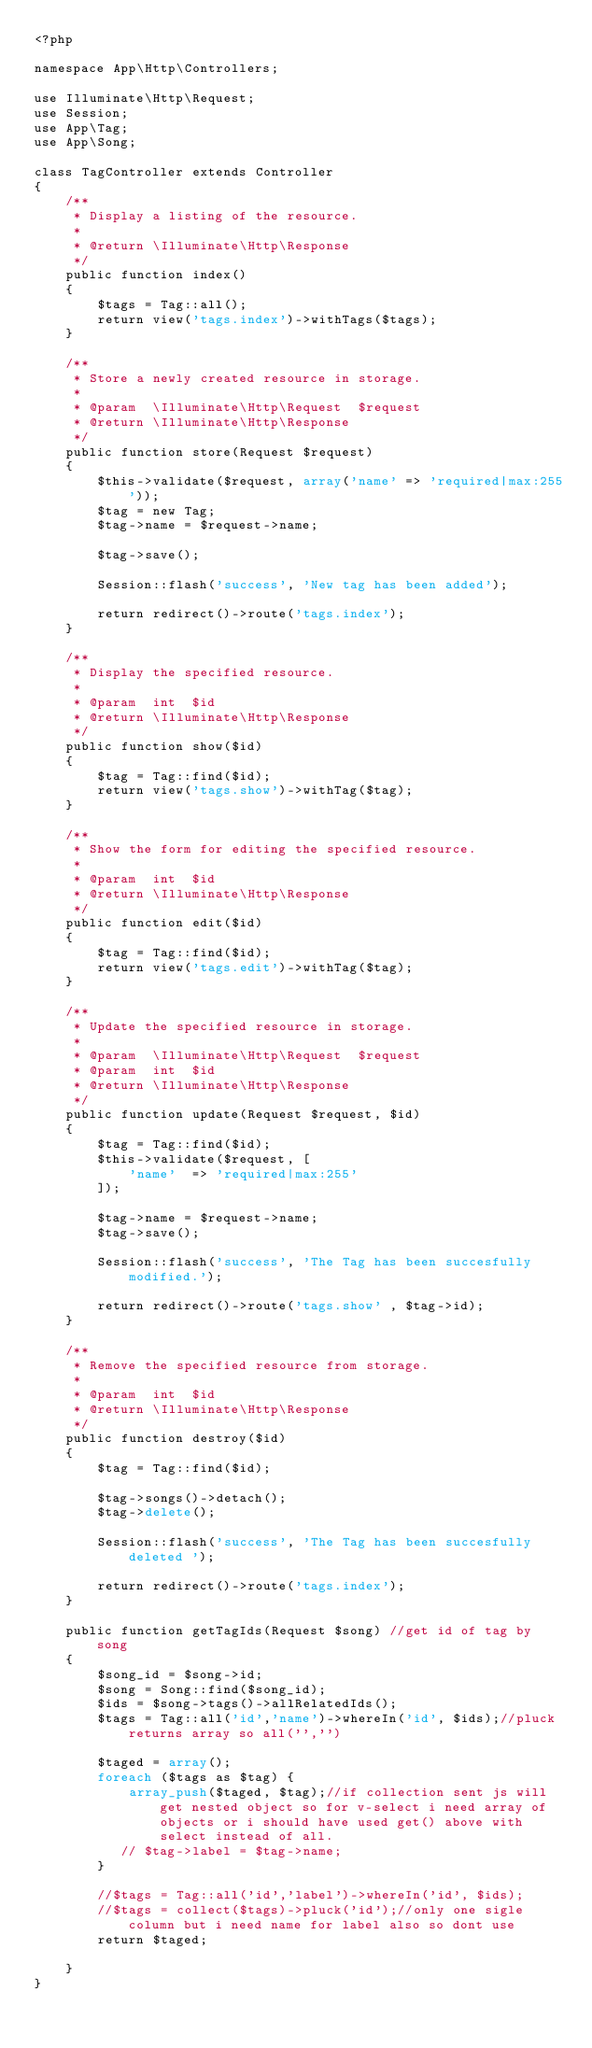Convert code to text. <code><loc_0><loc_0><loc_500><loc_500><_PHP_><?php

namespace App\Http\Controllers;

use Illuminate\Http\Request;
use Session;
use App\Tag;
use App\Song;

class TagController extends Controller
{
    /**
     * Display a listing of the resource.
     *
     * @return \Illuminate\Http\Response
     */
    public function index()
    {
        $tags = Tag::all();
        return view('tags.index')->withTags($tags);
    }

    /**
     * Store a newly created resource in storage.
     *
     * @param  \Illuminate\Http\Request  $request
     * @return \Illuminate\Http\Response
     */
    public function store(Request $request)
    {
        $this->validate($request, array('name' => 'required|max:255'));
        $tag = new Tag;
        $tag->name = $request->name;

        $tag->save();

        Session::flash('success', 'New tag has been added');

        return redirect()->route('tags.index');
    }

    /**
     * Display the specified resource.
     *
     * @param  int  $id
     * @return \Illuminate\Http\Response
     */
    public function show($id)
    {
        $tag = Tag::find($id);
        return view('tags.show')->withTag($tag);
    }

    /**
     * Show the form for editing the specified resource.
     *
     * @param  int  $id
     * @return \Illuminate\Http\Response
     */
    public function edit($id)
    {
        $tag = Tag::find($id);
        return view('tags.edit')->withTag($tag);
    }

    /**
     * Update the specified resource in storage.
     *
     * @param  \Illuminate\Http\Request  $request
     * @param  int  $id
     * @return \Illuminate\Http\Response
     */
    public function update(Request $request, $id)
    {   
        $tag = Tag::find($id);
        $this->validate($request, [
            'name'  => 'required|max:255'
        ]);

        $tag->name = $request->name;
        $tag->save(); 

        Session::flash('success', 'The Tag has been succesfully modified.');

        return redirect()->route('tags.show' , $tag->id);
    }

    /**
     * Remove the specified resource from storage.
     *
     * @param  int  $id
     * @return \Illuminate\Http\Response
     */
    public function destroy($id)
    {
        $tag = Tag::find($id);

        $tag->songs()->detach();
        $tag->delete();

        Session::flash('success', 'The Tag has been succesfully deleted ');

        return redirect()->route('tags.index');
    }

    public function getTagIds(Request $song) //get id of tag by song 
    { 
        $song_id = $song->id;
        $song = Song::find($song_id);
        $ids = $song->tags()->allRelatedIds();
        $tags = Tag::all('id','name')->whereIn('id', $ids);//pluck returns array so all('','')

        $taged = array();
        foreach ($tags as $tag) {
            array_push($taged, $tag);//if collection sent js will get nested object so for v-select i need array of objects or i should have used get() above with select instead of all.
           // $tag->label = $tag->name;
        }

        //$tags = Tag::all('id','label')->whereIn('id', $ids);
        //$tags = collect($tags)->pluck('id');//only one sigle column but i need name for label also so dont use 
        return $taged;

    }
}
</code> 